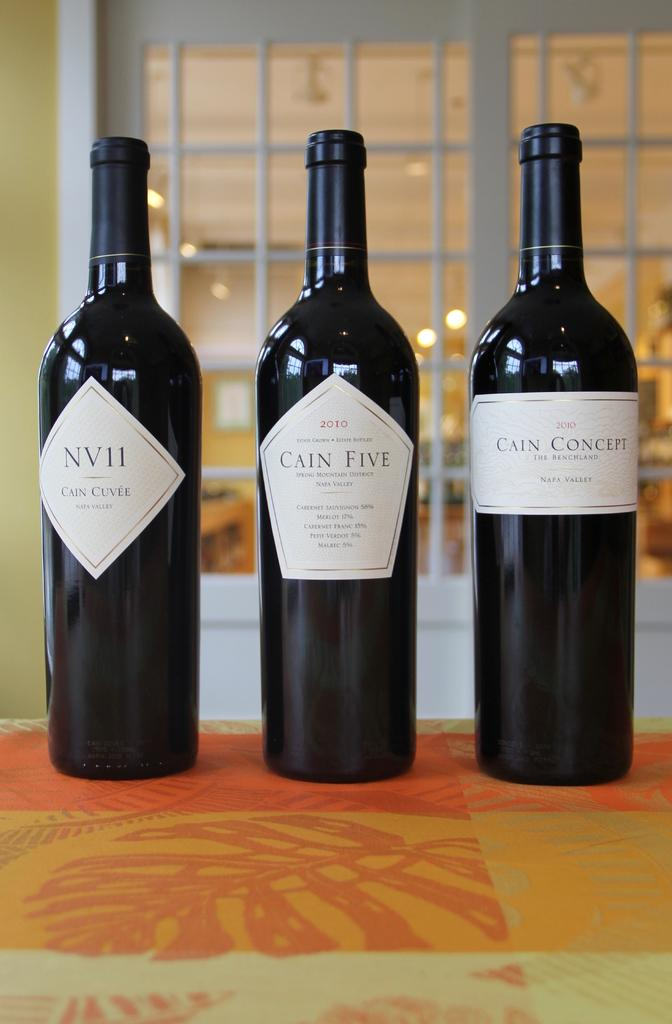<image>
Create a compact narrative representing the image presented. Three bottles of wine, NV11 Cain Cuvee, Cain Five, and Cain Concept. 